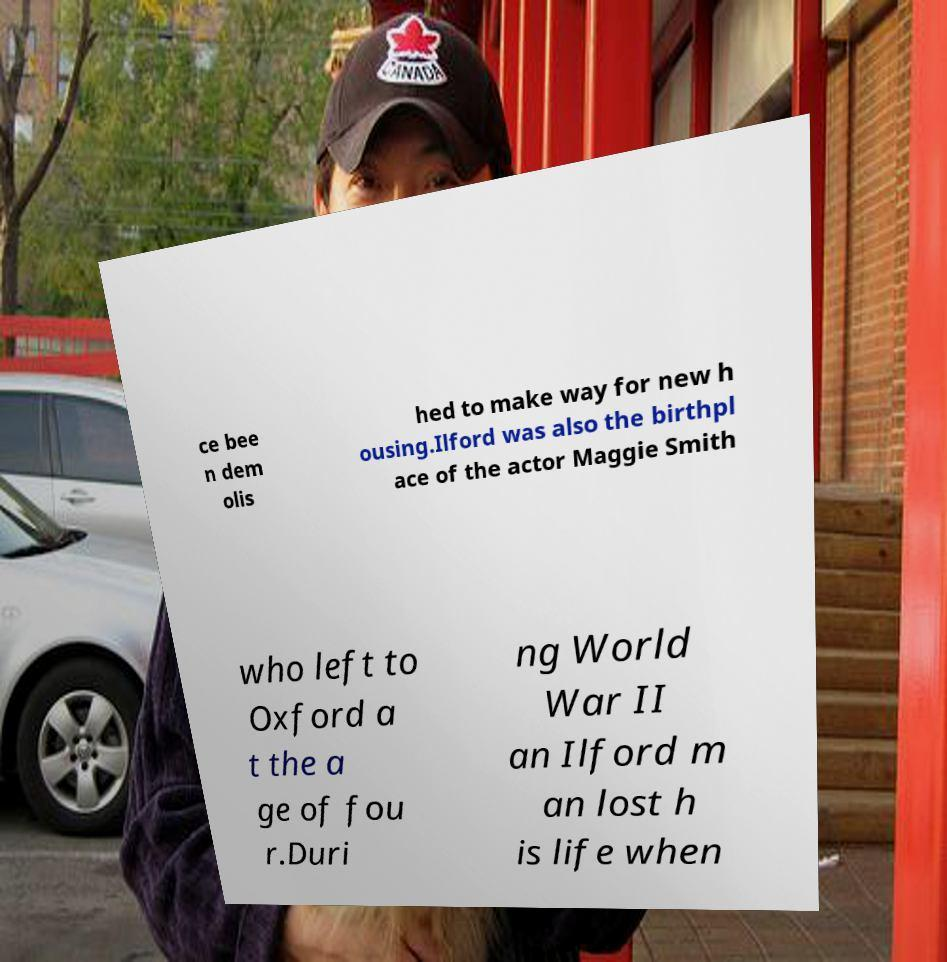Can you accurately transcribe the text from the provided image for me? ce bee n dem olis hed to make way for new h ousing.Ilford was also the birthpl ace of the actor Maggie Smith who left to Oxford a t the a ge of fou r.Duri ng World War II an Ilford m an lost h is life when 